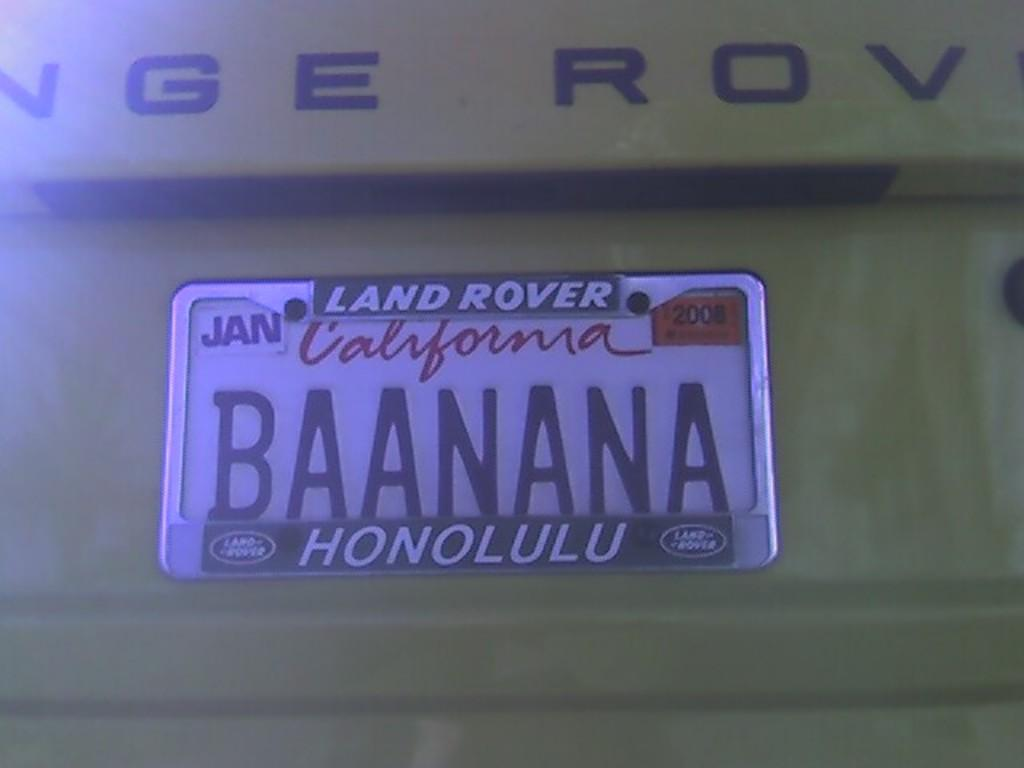<image>
Provide a brief description of the given image. A white California license plate reads "BAANANA" in black font. 